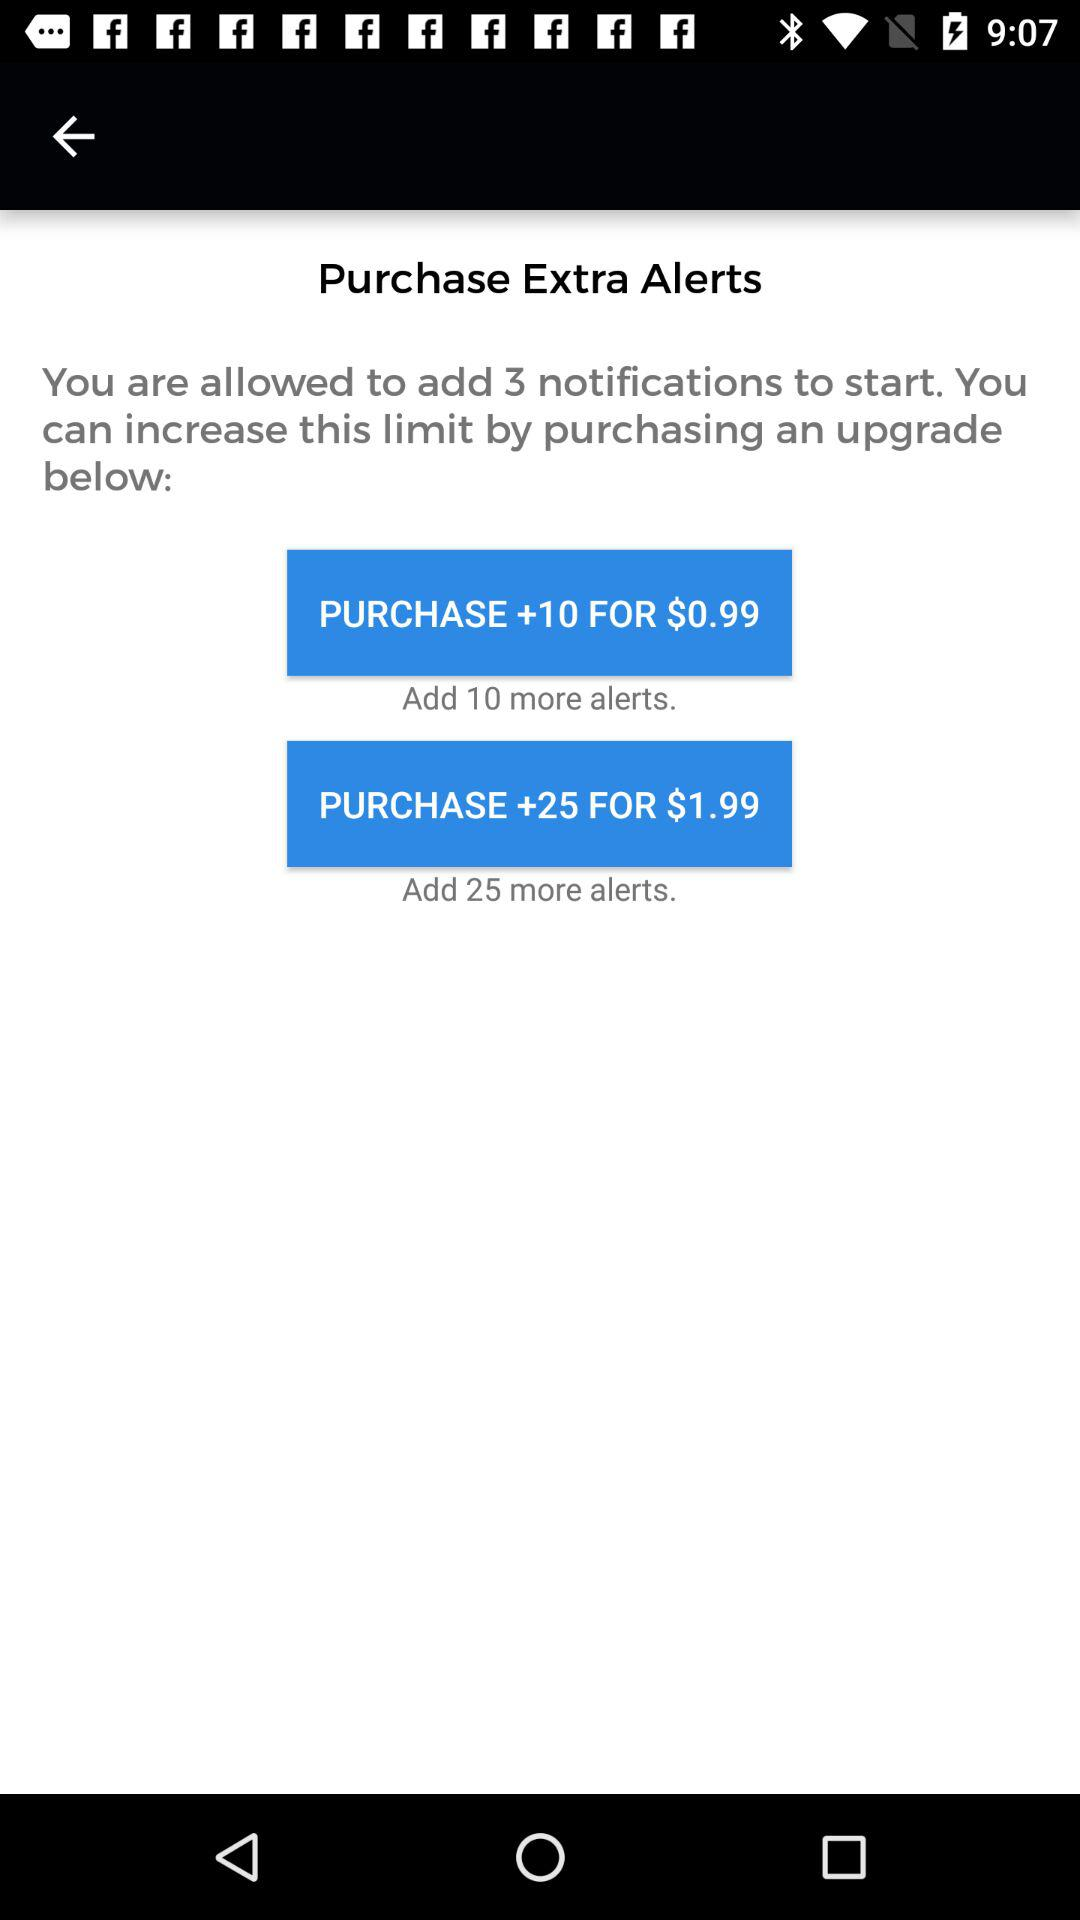What is the price for purchasing 10 extra alerts? The price for purchasing 10 extra alerts is $0.99. 